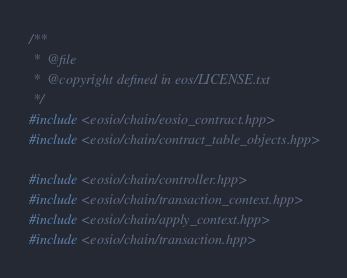Convert code to text. <code><loc_0><loc_0><loc_500><loc_500><_C++_>/**
 *  @file
 *  @copyright defined in eos/LICENSE.txt
 */
#include <eosio/chain/eosio_contract.hpp>
#include <eosio/chain/contract_table_objects.hpp>

#include <eosio/chain/controller.hpp>
#include <eosio/chain/transaction_context.hpp>
#include <eosio/chain/apply_context.hpp>
#include <eosio/chain/transaction.hpp></code> 